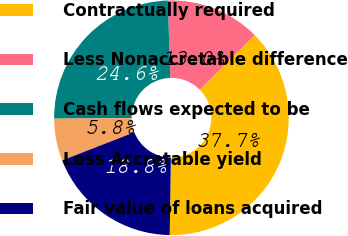Convert chart. <chart><loc_0><loc_0><loc_500><loc_500><pie_chart><fcel>Contractually required<fcel>Less Nonaccretable difference<fcel>Cash flows expected to be<fcel>Less Accretable yield<fcel>Fair value of loans acquired<nl><fcel>37.68%<fcel>13.05%<fcel>24.64%<fcel>5.8%<fcel>18.84%<nl></chart> 